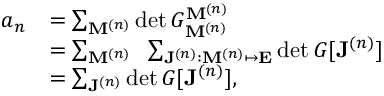<formula> <loc_0><loc_0><loc_500><loc_500>\begin{array} { r l } { a _ { n } } & { = \sum _ { M ^ { ( n ) } } \det G _ { M ^ { ( n ) } } ^ { M ^ { ( n ) } } } \\ & { = \sum _ { M ^ { ( n ) } } \, \sum _ { J ^ { ( n ) } \colon M ^ { ( n ) } \mapsto E } \det G [ J ^ { ( n ) } ] } \\ & { = \sum _ { J ^ { ( n ) } } \det G [ J ^ { ( n ) } ] , } \end{array}</formula> 